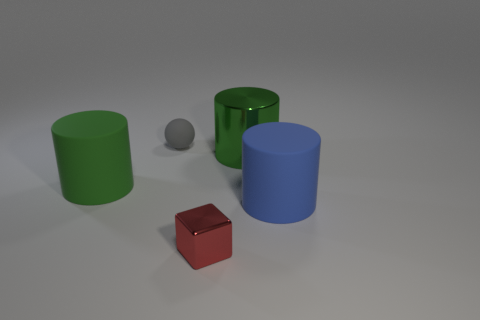How many other things are the same size as the green rubber object?
Keep it short and to the point. 2. Are the blue object and the tiny thing that is in front of the blue cylinder made of the same material?
Your answer should be compact. No. Are there the same number of small red cubes that are right of the blue cylinder and cylinders in front of the cube?
Keep it short and to the point. Yes. What is the material of the large blue cylinder?
Offer a terse response. Rubber. The thing that is the same size as the gray sphere is what color?
Offer a terse response. Red. Are there any small gray matte balls that are in front of the matte object that is on the left side of the matte ball?
Your answer should be compact. No. What number of blocks are either small red shiny objects or green matte objects?
Keep it short and to the point. 1. There is a green cylinder behind the matte cylinder that is to the left of the big metal object that is left of the big blue cylinder; what size is it?
Your answer should be very brief. Large. Are there any blue rubber cylinders behind the big green rubber cylinder?
Provide a succinct answer. No. How many objects are metallic objects that are right of the tiny red block or small red metal balls?
Ensure brevity in your answer.  1. 